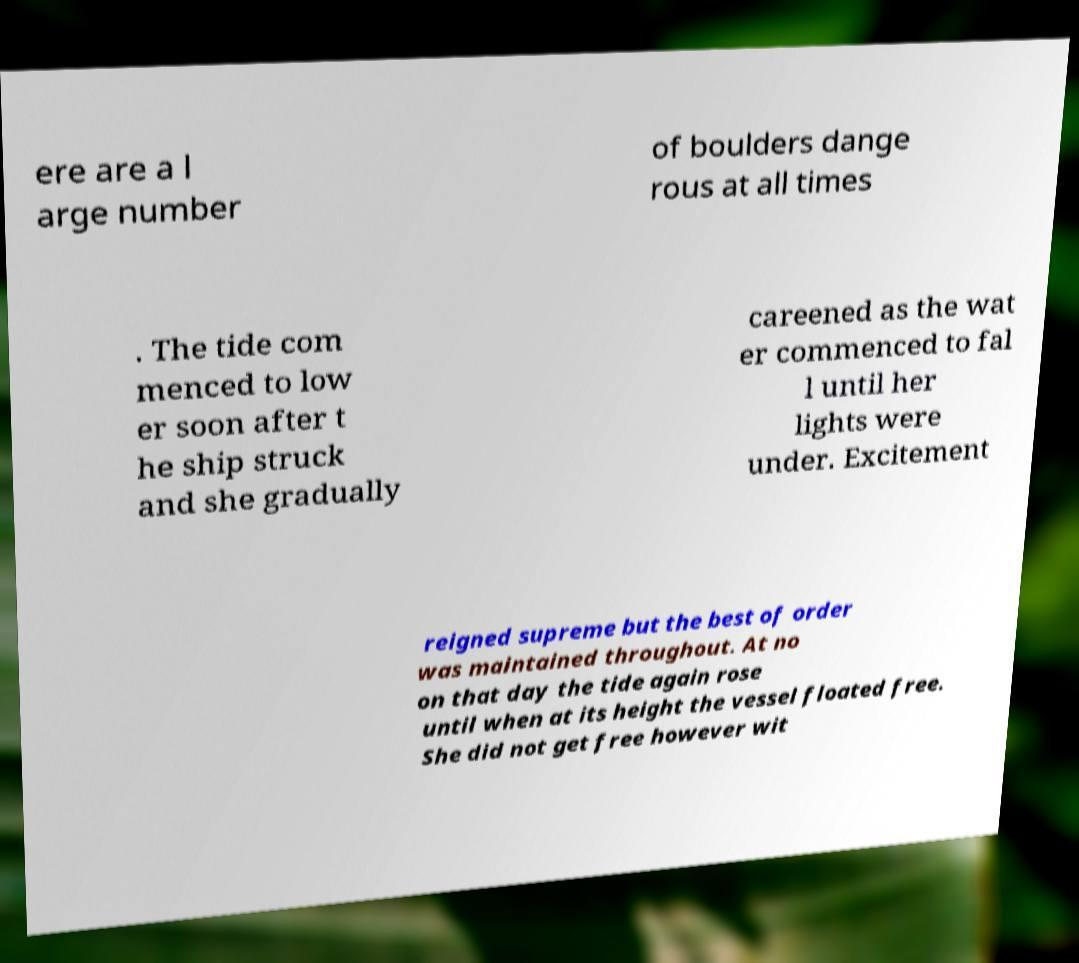I need the written content from this picture converted into text. Can you do that? ere are a l arge number of boulders dange rous at all times . The tide com menced to low er soon after t he ship struck and she gradually careened as the wat er commenced to fal l until her lights were under. Excitement reigned supreme but the best of order was maintained throughout. At no on that day the tide again rose until when at its height the vessel floated free. She did not get free however wit 